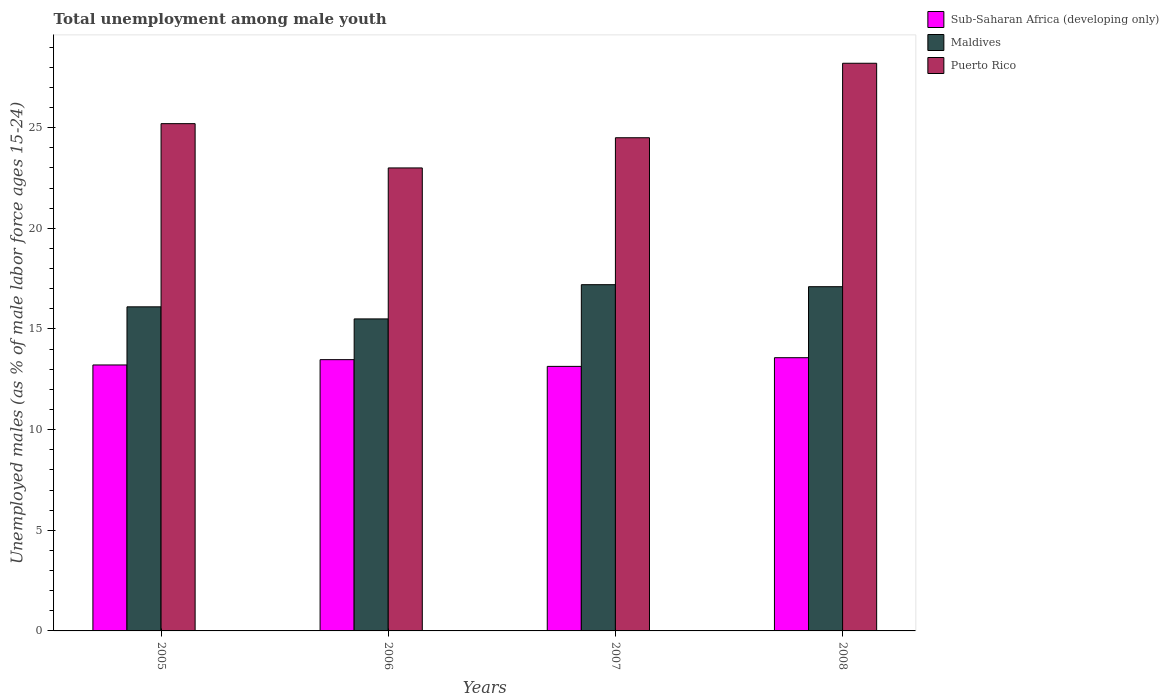In how many cases, is the number of bars for a given year not equal to the number of legend labels?
Keep it short and to the point. 0. What is the percentage of unemployed males in in Maldives in 2008?
Your answer should be compact. 17.1. Across all years, what is the maximum percentage of unemployed males in in Maldives?
Give a very brief answer. 17.2. Across all years, what is the minimum percentage of unemployed males in in Sub-Saharan Africa (developing only)?
Your answer should be very brief. 13.14. In which year was the percentage of unemployed males in in Sub-Saharan Africa (developing only) maximum?
Make the answer very short. 2008. In which year was the percentage of unemployed males in in Puerto Rico minimum?
Provide a short and direct response. 2006. What is the total percentage of unemployed males in in Maldives in the graph?
Your response must be concise. 65.9. What is the difference between the percentage of unemployed males in in Puerto Rico in 2006 and that in 2008?
Make the answer very short. -5.2. What is the difference between the percentage of unemployed males in in Sub-Saharan Africa (developing only) in 2005 and the percentage of unemployed males in in Maldives in 2006?
Make the answer very short. -2.29. What is the average percentage of unemployed males in in Sub-Saharan Africa (developing only) per year?
Make the answer very short. 13.35. In the year 2007, what is the difference between the percentage of unemployed males in in Puerto Rico and percentage of unemployed males in in Maldives?
Keep it short and to the point. 7.3. What is the ratio of the percentage of unemployed males in in Sub-Saharan Africa (developing only) in 2005 to that in 2006?
Offer a very short reply. 0.98. Is the difference between the percentage of unemployed males in in Puerto Rico in 2007 and 2008 greater than the difference between the percentage of unemployed males in in Maldives in 2007 and 2008?
Ensure brevity in your answer.  No. What is the difference between the highest and the lowest percentage of unemployed males in in Puerto Rico?
Provide a short and direct response. 5.2. In how many years, is the percentage of unemployed males in in Sub-Saharan Africa (developing only) greater than the average percentage of unemployed males in in Sub-Saharan Africa (developing only) taken over all years?
Provide a short and direct response. 2. Is the sum of the percentage of unemployed males in in Maldives in 2007 and 2008 greater than the maximum percentage of unemployed males in in Puerto Rico across all years?
Provide a succinct answer. Yes. What does the 1st bar from the left in 2005 represents?
Your answer should be compact. Sub-Saharan Africa (developing only). What does the 2nd bar from the right in 2007 represents?
Give a very brief answer. Maldives. Is it the case that in every year, the sum of the percentage of unemployed males in in Maldives and percentage of unemployed males in in Sub-Saharan Africa (developing only) is greater than the percentage of unemployed males in in Puerto Rico?
Offer a terse response. Yes. Are all the bars in the graph horizontal?
Keep it short and to the point. No. Are the values on the major ticks of Y-axis written in scientific E-notation?
Make the answer very short. No. Does the graph contain any zero values?
Your answer should be very brief. No. Where does the legend appear in the graph?
Your response must be concise. Top right. How many legend labels are there?
Ensure brevity in your answer.  3. What is the title of the graph?
Make the answer very short. Total unemployment among male youth. Does "Brazil" appear as one of the legend labels in the graph?
Ensure brevity in your answer.  No. What is the label or title of the Y-axis?
Offer a terse response. Unemployed males (as % of male labor force ages 15-24). What is the Unemployed males (as % of male labor force ages 15-24) in Sub-Saharan Africa (developing only) in 2005?
Keep it short and to the point. 13.21. What is the Unemployed males (as % of male labor force ages 15-24) in Maldives in 2005?
Your answer should be very brief. 16.1. What is the Unemployed males (as % of male labor force ages 15-24) of Puerto Rico in 2005?
Provide a short and direct response. 25.2. What is the Unemployed males (as % of male labor force ages 15-24) in Sub-Saharan Africa (developing only) in 2006?
Your answer should be compact. 13.48. What is the Unemployed males (as % of male labor force ages 15-24) of Puerto Rico in 2006?
Keep it short and to the point. 23. What is the Unemployed males (as % of male labor force ages 15-24) of Sub-Saharan Africa (developing only) in 2007?
Keep it short and to the point. 13.14. What is the Unemployed males (as % of male labor force ages 15-24) in Maldives in 2007?
Provide a succinct answer. 17.2. What is the Unemployed males (as % of male labor force ages 15-24) of Puerto Rico in 2007?
Offer a very short reply. 24.5. What is the Unemployed males (as % of male labor force ages 15-24) of Sub-Saharan Africa (developing only) in 2008?
Give a very brief answer. 13.57. What is the Unemployed males (as % of male labor force ages 15-24) in Maldives in 2008?
Offer a very short reply. 17.1. What is the Unemployed males (as % of male labor force ages 15-24) of Puerto Rico in 2008?
Your response must be concise. 28.2. Across all years, what is the maximum Unemployed males (as % of male labor force ages 15-24) in Sub-Saharan Africa (developing only)?
Your answer should be compact. 13.57. Across all years, what is the maximum Unemployed males (as % of male labor force ages 15-24) of Maldives?
Your answer should be compact. 17.2. Across all years, what is the maximum Unemployed males (as % of male labor force ages 15-24) in Puerto Rico?
Keep it short and to the point. 28.2. Across all years, what is the minimum Unemployed males (as % of male labor force ages 15-24) of Sub-Saharan Africa (developing only)?
Offer a terse response. 13.14. Across all years, what is the minimum Unemployed males (as % of male labor force ages 15-24) of Maldives?
Ensure brevity in your answer.  15.5. What is the total Unemployed males (as % of male labor force ages 15-24) in Sub-Saharan Africa (developing only) in the graph?
Make the answer very short. 53.4. What is the total Unemployed males (as % of male labor force ages 15-24) in Maldives in the graph?
Make the answer very short. 65.9. What is the total Unemployed males (as % of male labor force ages 15-24) in Puerto Rico in the graph?
Offer a very short reply. 100.9. What is the difference between the Unemployed males (as % of male labor force ages 15-24) of Sub-Saharan Africa (developing only) in 2005 and that in 2006?
Your answer should be very brief. -0.26. What is the difference between the Unemployed males (as % of male labor force ages 15-24) of Puerto Rico in 2005 and that in 2006?
Give a very brief answer. 2.2. What is the difference between the Unemployed males (as % of male labor force ages 15-24) of Sub-Saharan Africa (developing only) in 2005 and that in 2007?
Provide a succinct answer. 0.07. What is the difference between the Unemployed males (as % of male labor force ages 15-24) in Maldives in 2005 and that in 2007?
Your answer should be very brief. -1.1. What is the difference between the Unemployed males (as % of male labor force ages 15-24) in Puerto Rico in 2005 and that in 2007?
Keep it short and to the point. 0.7. What is the difference between the Unemployed males (as % of male labor force ages 15-24) of Sub-Saharan Africa (developing only) in 2005 and that in 2008?
Your answer should be very brief. -0.36. What is the difference between the Unemployed males (as % of male labor force ages 15-24) of Sub-Saharan Africa (developing only) in 2006 and that in 2007?
Your answer should be compact. 0.33. What is the difference between the Unemployed males (as % of male labor force ages 15-24) of Maldives in 2006 and that in 2007?
Your answer should be very brief. -1.7. What is the difference between the Unemployed males (as % of male labor force ages 15-24) in Sub-Saharan Africa (developing only) in 2006 and that in 2008?
Keep it short and to the point. -0.1. What is the difference between the Unemployed males (as % of male labor force ages 15-24) in Maldives in 2006 and that in 2008?
Provide a short and direct response. -1.6. What is the difference between the Unemployed males (as % of male labor force ages 15-24) of Puerto Rico in 2006 and that in 2008?
Ensure brevity in your answer.  -5.2. What is the difference between the Unemployed males (as % of male labor force ages 15-24) in Sub-Saharan Africa (developing only) in 2007 and that in 2008?
Make the answer very short. -0.43. What is the difference between the Unemployed males (as % of male labor force ages 15-24) of Sub-Saharan Africa (developing only) in 2005 and the Unemployed males (as % of male labor force ages 15-24) of Maldives in 2006?
Your response must be concise. -2.29. What is the difference between the Unemployed males (as % of male labor force ages 15-24) in Sub-Saharan Africa (developing only) in 2005 and the Unemployed males (as % of male labor force ages 15-24) in Puerto Rico in 2006?
Your answer should be compact. -9.79. What is the difference between the Unemployed males (as % of male labor force ages 15-24) in Sub-Saharan Africa (developing only) in 2005 and the Unemployed males (as % of male labor force ages 15-24) in Maldives in 2007?
Ensure brevity in your answer.  -3.99. What is the difference between the Unemployed males (as % of male labor force ages 15-24) in Sub-Saharan Africa (developing only) in 2005 and the Unemployed males (as % of male labor force ages 15-24) in Puerto Rico in 2007?
Your answer should be very brief. -11.29. What is the difference between the Unemployed males (as % of male labor force ages 15-24) of Sub-Saharan Africa (developing only) in 2005 and the Unemployed males (as % of male labor force ages 15-24) of Maldives in 2008?
Keep it short and to the point. -3.89. What is the difference between the Unemployed males (as % of male labor force ages 15-24) in Sub-Saharan Africa (developing only) in 2005 and the Unemployed males (as % of male labor force ages 15-24) in Puerto Rico in 2008?
Give a very brief answer. -14.99. What is the difference between the Unemployed males (as % of male labor force ages 15-24) in Maldives in 2005 and the Unemployed males (as % of male labor force ages 15-24) in Puerto Rico in 2008?
Ensure brevity in your answer.  -12.1. What is the difference between the Unemployed males (as % of male labor force ages 15-24) of Sub-Saharan Africa (developing only) in 2006 and the Unemployed males (as % of male labor force ages 15-24) of Maldives in 2007?
Your response must be concise. -3.72. What is the difference between the Unemployed males (as % of male labor force ages 15-24) of Sub-Saharan Africa (developing only) in 2006 and the Unemployed males (as % of male labor force ages 15-24) of Puerto Rico in 2007?
Your response must be concise. -11.02. What is the difference between the Unemployed males (as % of male labor force ages 15-24) of Maldives in 2006 and the Unemployed males (as % of male labor force ages 15-24) of Puerto Rico in 2007?
Provide a short and direct response. -9. What is the difference between the Unemployed males (as % of male labor force ages 15-24) in Sub-Saharan Africa (developing only) in 2006 and the Unemployed males (as % of male labor force ages 15-24) in Maldives in 2008?
Your answer should be very brief. -3.62. What is the difference between the Unemployed males (as % of male labor force ages 15-24) of Sub-Saharan Africa (developing only) in 2006 and the Unemployed males (as % of male labor force ages 15-24) of Puerto Rico in 2008?
Give a very brief answer. -14.72. What is the difference between the Unemployed males (as % of male labor force ages 15-24) in Sub-Saharan Africa (developing only) in 2007 and the Unemployed males (as % of male labor force ages 15-24) in Maldives in 2008?
Your answer should be compact. -3.96. What is the difference between the Unemployed males (as % of male labor force ages 15-24) in Sub-Saharan Africa (developing only) in 2007 and the Unemployed males (as % of male labor force ages 15-24) in Puerto Rico in 2008?
Your response must be concise. -15.06. What is the difference between the Unemployed males (as % of male labor force ages 15-24) of Maldives in 2007 and the Unemployed males (as % of male labor force ages 15-24) of Puerto Rico in 2008?
Your answer should be very brief. -11. What is the average Unemployed males (as % of male labor force ages 15-24) of Sub-Saharan Africa (developing only) per year?
Your response must be concise. 13.35. What is the average Unemployed males (as % of male labor force ages 15-24) of Maldives per year?
Ensure brevity in your answer.  16.48. What is the average Unemployed males (as % of male labor force ages 15-24) in Puerto Rico per year?
Your answer should be compact. 25.23. In the year 2005, what is the difference between the Unemployed males (as % of male labor force ages 15-24) of Sub-Saharan Africa (developing only) and Unemployed males (as % of male labor force ages 15-24) of Maldives?
Your answer should be very brief. -2.89. In the year 2005, what is the difference between the Unemployed males (as % of male labor force ages 15-24) of Sub-Saharan Africa (developing only) and Unemployed males (as % of male labor force ages 15-24) of Puerto Rico?
Your answer should be compact. -11.99. In the year 2005, what is the difference between the Unemployed males (as % of male labor force ages 15-24) of Maldives and Unemployed males (as % of male labor force ages 15-24) of Puerto Rico?
Give a very brief answer. -9.1. In the year 2006, what is the difference between the Unemployed males (as % of male labor force ages 15-24) of Sub-Saharan Africa (developing only) and Unemployed males (as % of male labor force ages 15-24) of Maldives?
Provide a succinct answer. -2.02. In the year 2006, what is the difference between the Unemployed males (as % of male labor force ages 15-24) in Sub-Saharan Africa (developing only) and Unemployed males (as % of male labor force ages 15-24) in Puerto Rico?
Your response must be concise. -9.52. In the year 2006, what is the difference between the Unemployed males (as % of male labor force ages 15-24) in Maldives and Unemployed males (as % of male labor force ages 15-24) in Puerto Rico?
Your answer should be very brief. -7.5. In the year 2007, what is the difference between the Unemployed males (as % of male labor force ages 15-24) of Sub-Saharan Africa (developing only) and Unemployed males (as % of male labor force ages 15-24) of Maldives?
Offer a terse response. -4.06. In the year 2007, what is the difference between the Unemployed males (as % of male labor force ages 15-24) of Sub-Saharan Africa (developing only) and Unemployed males (as % of male labor force ages 15-24) of Puerto Rico?
Ensure brevity in your answer.  -11.36. In the year 2008, what is the difference between the Unemployed males (as % of male labor force ages 15-24) of Sub-Saharan Africa (developing only) and Unemployed males (as % of male labor force ages 15-24) of Maldives?
Make the answer very short. -3.53. In the year 2008, what is the difference between the Unemployed males (as % of male labor force ages 15-24) in Sub-Saharan Africa (developing only) and Unemployed males (as % of male labor force ages 15-24) in Puerto Rico?
Your answer should be very brief. -14.63. In the year 2008, what is the difference between the Unemployed males (as % of male labor force ages 15-24) of Maldives and Unemployed males (as % of male labor force ages 15-24) of Puerto Rico?
Your answer should be compact. -11.1. What is the ratio of the Unemployed males (as % of male labor force ages 15-24) of Sub-Saharan Africa (developing only) in 2005 to that in 2006?
Your answer should be very brief. 0.98. What is the ratio of the Unemployed males (as % of male labor force ages 15-24) in Maldives in 2005 to that in 2006?
Provide a succinct answer. 1.04. What is the ratio of the Unemployed males (as % of male labor force ages 15-24) of Puerto Rico in 2005 to that in 2006?
Your answer should be very brief. 1.1. What is the ratio of the Unemployed males (as % of male labor force ages 15-24) in Sub-Saharan Africa (developing only) in 2005 to that in 2007?
Give a very brief answer. 1.01. What is the ratio of the Unemployed males (as % of male labor force ages 15-24) of Maldives in 2005 to that in 2007?
Provide a short and direct response. 0.94. What is the ratio of the Unemployed males (as % of male labor force ages 15-24) in Puerto Rico in 2005 to that in 2007?
Your answer should be very brief. 1.03. What is the ratio of the Unemployed males (as % of male labor force ages 15-24) in Sub-Saharan Africa (developing only) in 2005 to that in 2008?
Your answer should be compact. 0.97. What is the ratio of the Unemployed males (as % of male labor force ages 15-24) of Maldives in 2005 to that in 2008?
Give a very brief answer. 0.94. What is the ratio of the Unemployed males (as % of male labor force ages 15-24) of Puerto Rico in 2005 to that in 2008?
Ensure brevity in your answer.  0.89. What is the ratio of the Unemployed males (as % of male labor force ages 15-24) of Sub-Saharan Africa (developing only) in 2006 to that in 2007?
Offer a terse response. 1.03. What is the ratio of the Unemployed males (as % of male labor force ages 15-24) of Maldives in 2006 to that in 2007?
Provide a succinct answer. 0.9. What is the ratio of the Unemployed males (as % of male labor force ages 15-24) of Puerto Rico in 2006 to that in 2007?
Your answer should be compact. 0.94. What is the ratio of the Unemployed males (as % of male labor force ages 15-24) of Maldives in 2006 to that in 2008?
Your response must be concise. 0.91. What is the ratio of the Unemployed males (as % of male labor force ages 15-24) of Puerto Rico in 2006 to that in 2008?
Offer a very short reply. 0.82. What is the ratio of the Unemployed males (as % of male labor force ages 15-24) in Sub-Saharan Africa (developing only) in 2007 to that in 2008?
Provide a succinct answer. 0.97. What is the ratio of the Unemployed males (as % of male labor force ages 15-24) in Maldives in 2007 to that in 2008?
Offer a very short reply. 1.01. What is the ratio of the Unemployed males (as % of male labor force ages 15-24) in Puerto Rico in 2007 to that in 2008?
Ensure brevity in your answer.  0.87. What is the difference between the highest and the second highest Unemployed males (as % of male labor force ages 15-24) in Sub-Saharan Africa (developing only)?
Your answer should be compact. 0.1. What is the difference between the highest and the second highest Unemployed males (as % of male labor force ages 15-24) in Puerto Rico?
Provide a short and direct response. 3. What is the difference between the highest and the lowest Unemployed males (as % of male labor force ages 15-24) in Sub-Saharan Africa (developing only)?
Your answer should be very brief. 0.43. What is the difference between the highest and the lowest Unemployed males (as % of male labor force ages 15-24) of Maldives?
Ensure brevity in your answer.  1.7. 